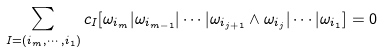Convert formula to latex. <formula><loc_0><loc_0><loc_500><loc_500>\sum _ { I = ( i _ { m } , \cdots , i _ { 1 } ) } c _ { I } [ \omega _ { i _ { m } } | \omega _ { i _ { m - 1 } } | \cdots | \omega _ { i _ { j + 1 } } \wedge \omega _ { i _ { j } } | \cdots | \omega _ { i _ { 1 } } ] = 0</formula> 